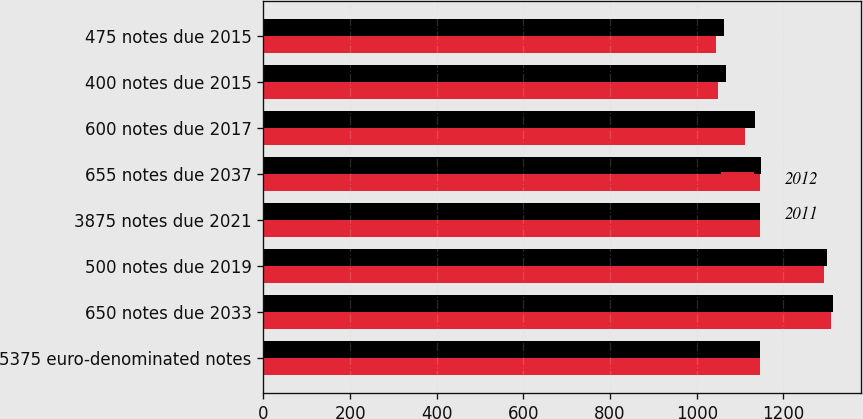<chart> <loc_0><loc_0><loc_500><loc_500><stacked_bar_chart><ecel><fcel>5375 euro-denominated notes<fcel>650 notes due 2033<fcel>500 notes due 2019<fcel>3875 notes due 2021<fcel>655 notes due 2037<fcel>600 notes due 2017<fcel>400 notes due 2015<fcel>475 notes due 2015<nl><fcel>2012<fcel>1146.5<fcel>1310<fcel>1294<fcel>1147<fcel>1146<fcel>1112<fcel>1049<fcel>1044<nl><fcel>2011<fcel>1146.5<fcel>1314<fcel>1300<fcel>1147<fcel>1148<fcel>1134<fcel>1068<fcel>1064<nl></chart> 